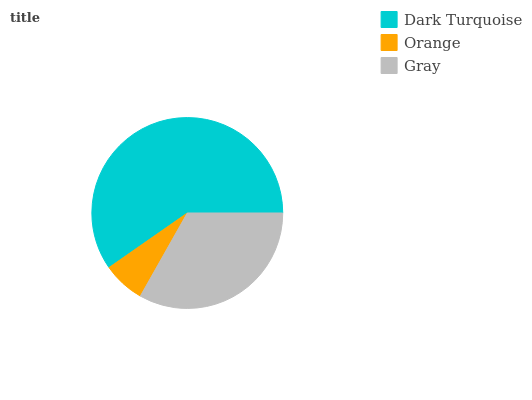Is Orange the minimum?
Answer yes or no. Yes. Is Dark Turquoise the maximum?
Answer yes or no. Yes. Is Gray the minimum?
Answer yes or no. No. Is Gray the maximum?
Answer yes or no. No. Is Gray greater than Orange?
Answer yes or no. Yes. Is Orange less than Gray?
Answer yes or no. Yes. Is Orange greater than Gray?
Answer yes or no. No. Is Gray less than Orange?
Answer yes or no. No. Is Gray the high median?
Answer yes or no. Yes. Is Gray the low median?
Answer yes or no. Yes. Is Dark Turquoise the high median?
Answer yes or no. No. Is Orange the low median?
Answer yes or no. No. 